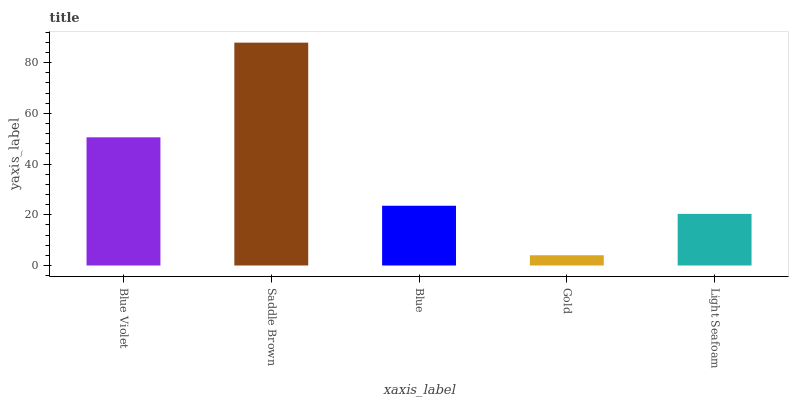Is Blue the minimum?
Answer yes or no. No. Is Blue the maximum?
Answer yes or no. No. Is Saddle Brown greater than Blue?
Answer yes or no. Yes. Is Blue less than Saddle Brown?
Answer yes or no. Yes. Is Blue greater than Saddle Brown?
Answer yes or no. No. Is Saddle Brown less than Blue?
Answer yes or no. No. Is Blue the high median?
Answer yes or no. Yes. Is Blue the low median?
Answer yes or no. Yes. Is Light Seafoam the high median?
Answer yes or no. No. Is Gold the low median?
Answer yes or no. No. 